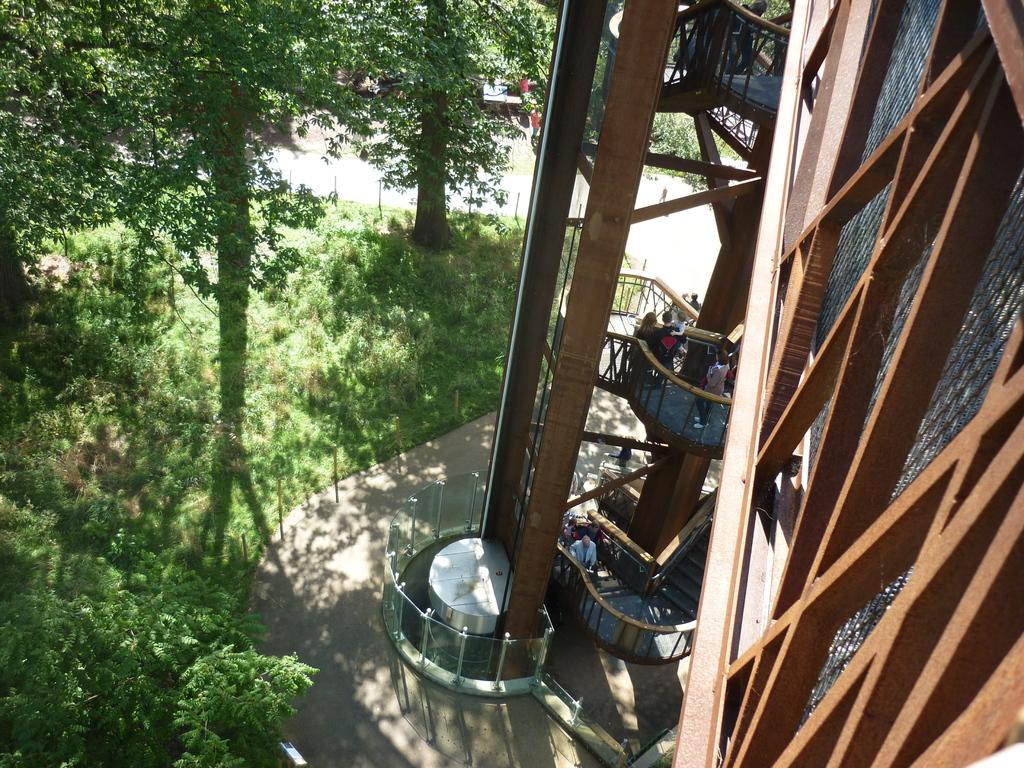Who or what can be seen in the image? There are people in the image. What structure is located on the right side of the image? There is a building on the right side of the image. What type of vegetation is visible in the image? There are plants visible in the image. What can be seen in the background of the image? There are trees in the background of the image. What type of appliance is visible on the left side of the image? There is no appliance visible in the image. What type of agreement is being discussed by the people in the image? There is no indication of an agreement being discussed in the image. 